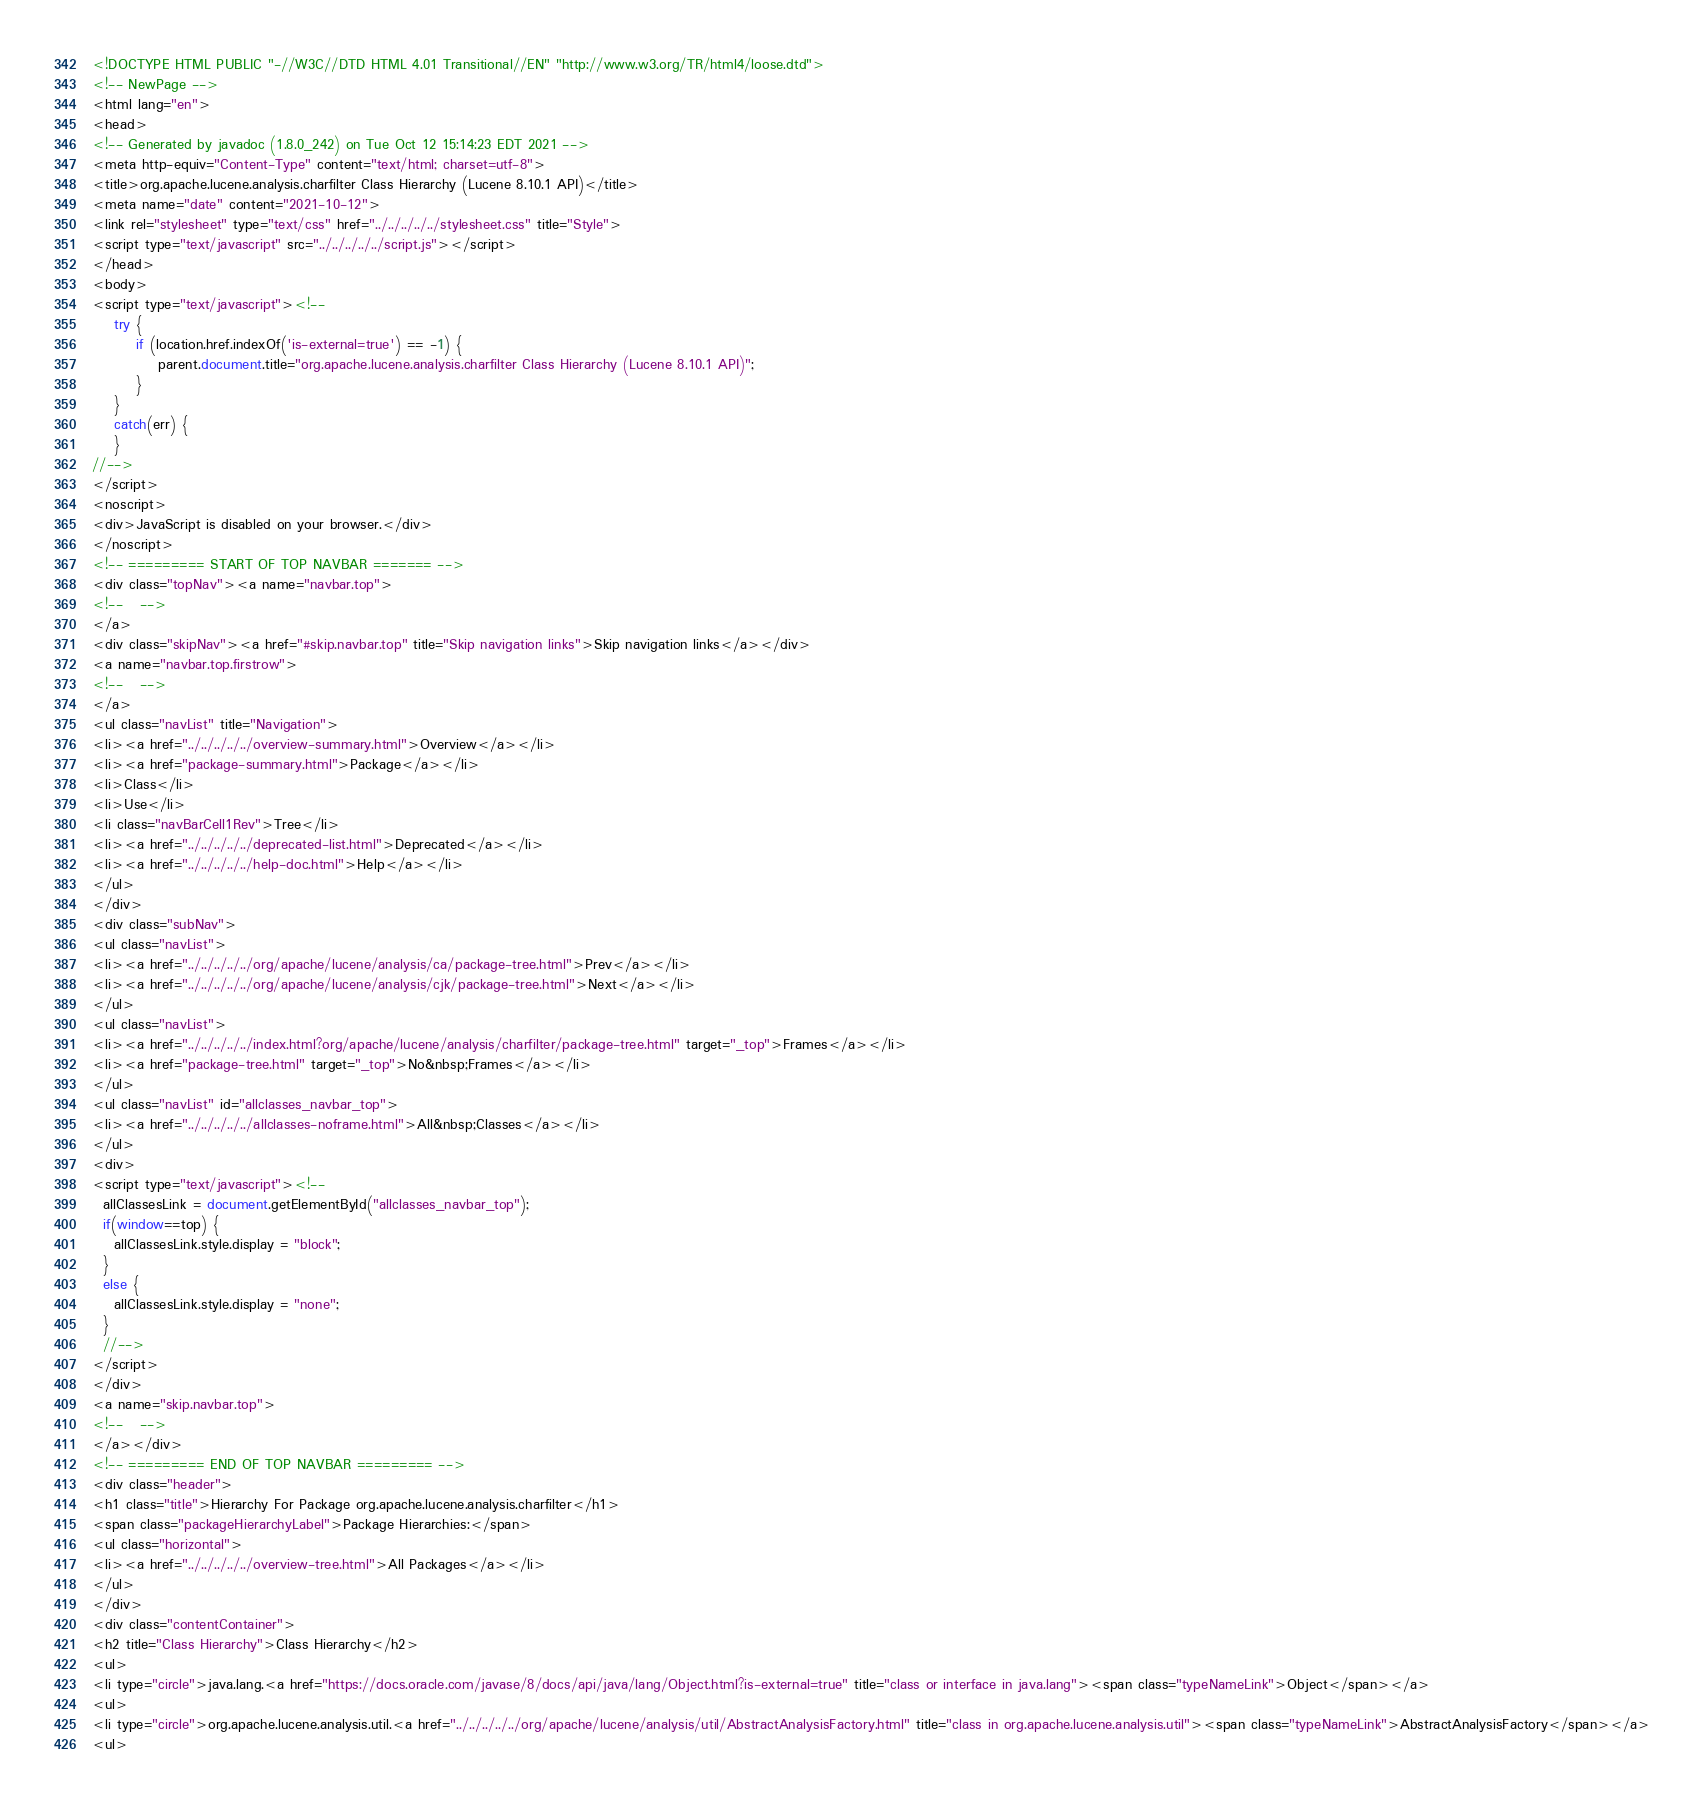<code> <loc_0><loc_0><loc_500><loc_500><_HTML_><!DOCTYPE HTML PUBLIC "-//W3C//DTD HTML 4.01 Transitional//EN" "http://www.w3.org/TR/html4/loose.dtd">
<!-- NewPage -->
<html lang="en">
<head>
<!-- Generated by javadoc (1.8.0_242) on Tue Oct 12 15:14:23 EDT 2021 -->
<meta http-equiv="Content-Type" content="text/html; charset=utf-8">
<title>org.apache.lucene.analysis.charfilter Class Hierarchy (Lucene 8.10.1 API)</title>
<meta name="date" content="2021-10-12">
<link rel="stylesheet" type="text/css" href="../../../../../stylesheet.css" title="Style">
<script type="text/javascript" src="../../../../../script.js"></script>
</head>
<body>
<script type="text/javascript"><!--
    try {
        if (location.href.indexOf('is-external=true') == -1) {
            parent.document.title="org.apache.lucene.analysis.charfilter Class Hierarchy (Lucene 8.10.1 API)";
        }
    }
    catch(err) {
    }
//-->
</script>
<noscript>
<div>JavaScript is disabled on your browser.</div>
</noscript>
<!-- ========= START OF TOP NAVBAR ======= -->
<div class="topNav"><a name="navbar.top">
<!--   -->
</a>
<div class="skipNav"><a href="#skip.navbar.top" title="Skip navigation links">Skip navigation links</a></div>
<a name="navbar.top.firstrow">
<!--   -->
</a>
<ul class="navList" title="Navigation">
<li><a href="../../../../../overview-summary.html">Overview</a></li>
<li><a href="package-summary.html">Package</a></li>
<li>Class</li>
<li>Use</li>
<li class="navBarCell1Rev">Tree</li>
<li><a href="../../../../../deprecated-list.html">Deprecated</a></li>
<li><a href="../../../../../help-doc.html">Help</a></li>
</ul>
</div>
<div class="subNav">
<ul class="navList">
<li><a href="../../../../../org/apache/lucene/analysis/ca/package-tree.html">Prev</a></li>
<li><a href="../../../../../org/apache/lucene/analysis/cjk/package-tree.html">Next</a></li>
</ul>
<ul class="navList">
<li><a href="../../../../../index.html?org/apache/lucene/analysis/charfilter/package-tree.html" target="_top">Frames</a></li>
<li><a href="package-tree.html" target="_top">No&nbsp;Frames</a></li>
</ul>
<ul class="navList" id="allclasses_navbar_top">
<li><a href="../../../../../allclasses-noframe.html">All&nbsp;Classes</a></li>
</ul>
<div>
<script type="text/javascript"><!--
  allClassesLink = document.getElementById("allclasses_navbar_top");
  if(window==top) {
    allClassesLink.style.display = "block";
  }
  else {
    allClassesLink.style.display = "none";
  }
  //-->
</script>
</div>
<a name="skip.navbar.top">
<!--   -->
</a></div>
<!-- ========= END OF TOP NAVBAR ========= -->
<div class="header">
<h1 class="title">Hierarchy For Package org.apache.lucene.analysis.charfilter</h1>
<span class="packageHierarchyLabel">Package Hierarchies:</span>
<ul class="horizontal">
<li><a href="../../../../../overview-tree.html">All Packages</a></li>
</ul>
</div>
<div class="contentContainer">
<h2 title="Class Hierarchy">Class Hierarchy</h2>
<ul>
<li type="circle">java.lang.<a href="https://docs.oracle.com/javase/8/docs/api/java/lang/Object.html?is-external=true" title="class or interface in java.lang"><span class="typeNameLink">Object</span></a>
<ul>
<li type="circle">org.apache.lucene.analysis.util.<a href="../../../../../org/apache/lucene/analysis/util/AbstractAnalysisFactory.html" title="class in org.apache.lucene.analysis.util"><span class="typeNameLink">AbstractAnalysisFactory</span></a>
<ul></code> 